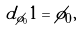<formula> <loc_0><loc_0><loc_500><loc_500>d _ { \phi _ { 0 } } 1 = \phi _ { 0 } ,</formula> 